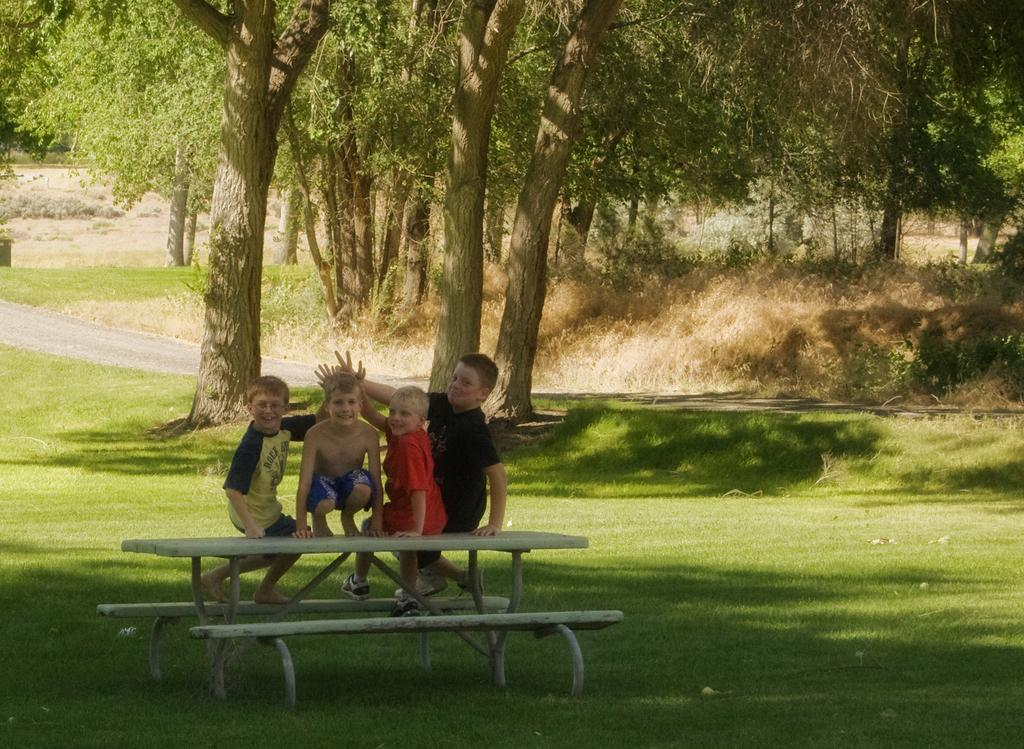How many boys are sitting on the bench in the image? There are four boys sitting on the bench in the image. What type of surface is visible at the bottom of the image? There is grass visible at the bottom of the image. What can be seen in the background of the image? There are trees and a road in the background of the image. What type of crime is being committed by the boys in the image? There is no indication of any crime being committed in the image; the boys are simply sitting on a bench. How much milk is being consumed by the boys in the image? There is no milk present in the image, so it cannot be determined how much the boys might be consuming. 